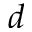<formula> <loc_0><loc_0><loc_500><loc_500>d</formula> 